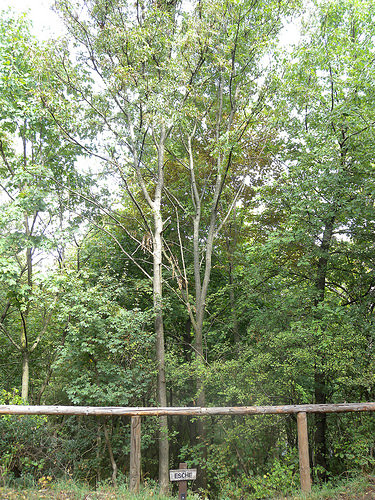<image>
Is the tree behind the sign? Yes. From this viewpoint, the tree is positioned behind the sign, with the sign partially or fully occluding the tree. 